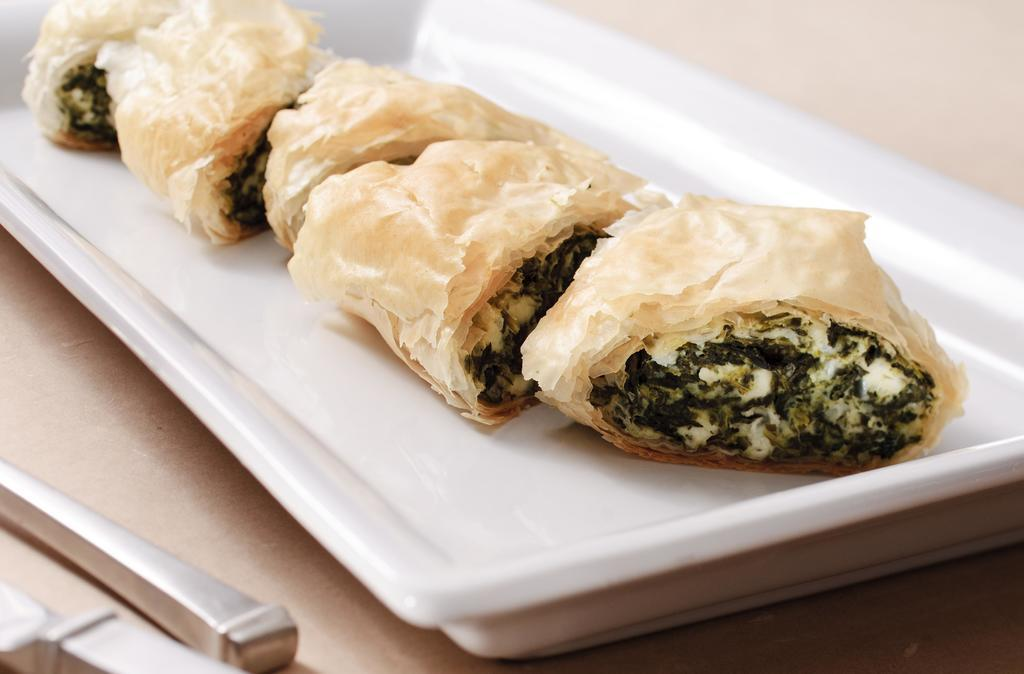What object can be seen in the image that is used for holding items? There is a tray in the image that is used for holding items. What is the color of the tray? The tray is white in color. What type of food item is present on the tray? There is a food item with a slice on the tray. What natural element is visible in the image? There is a tree in the image. What material is used for the objects placed on the table near the tree? The objects placed on the table near the tree are made of steel. How many houses can be seen in the image? There are no houses visible in the image. Can you describe the kiss between the two people in the image? There are no people or kisses present in the image. 